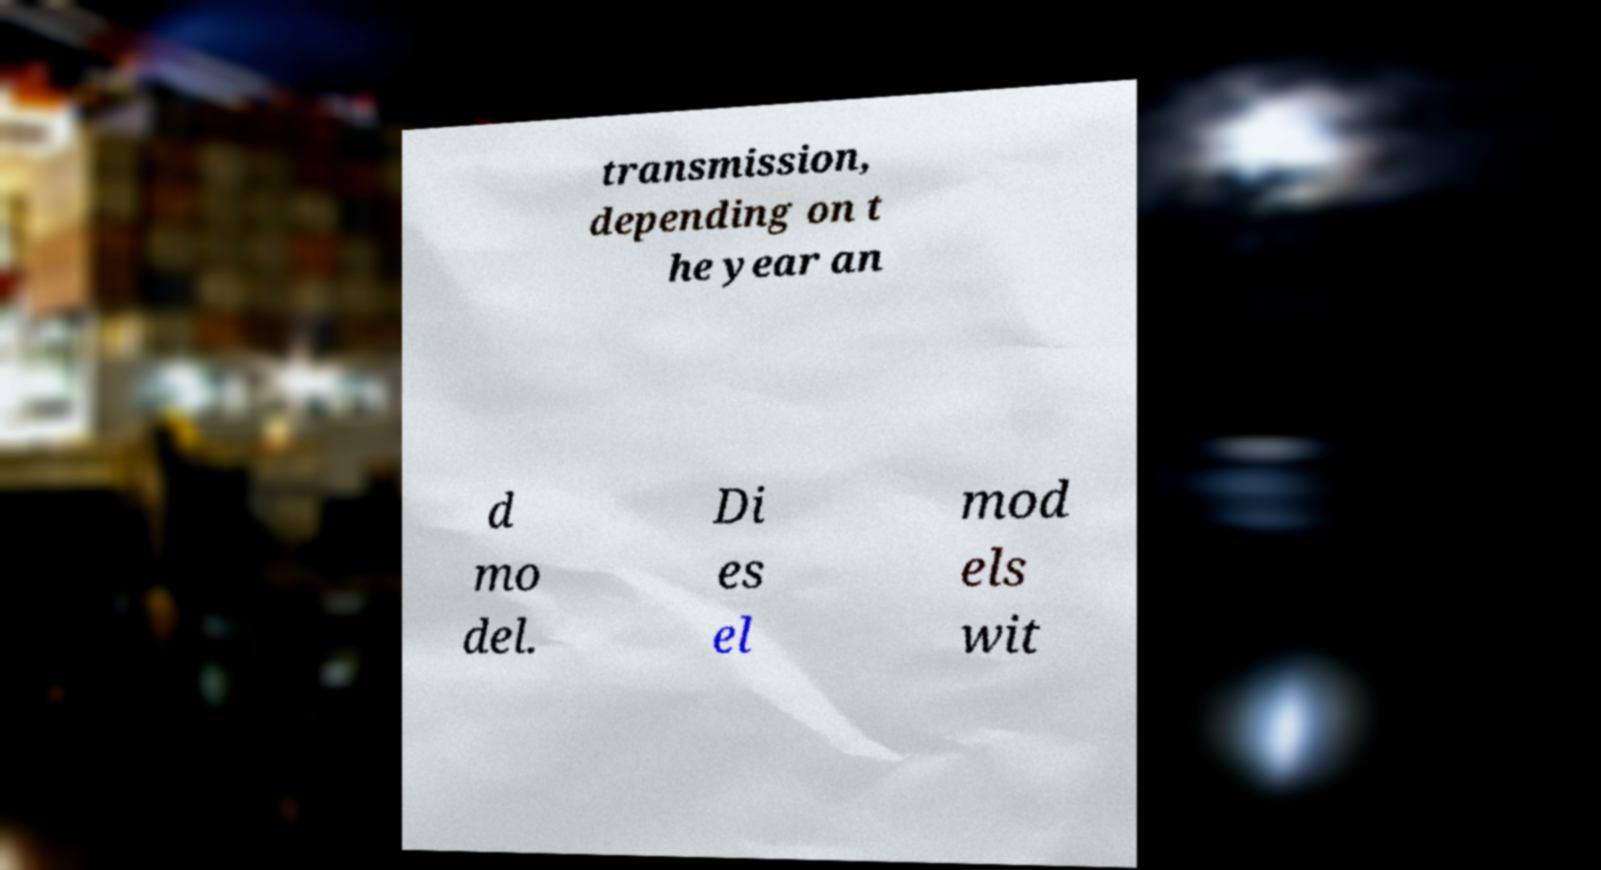There's text embedded in this image that I need extracted. Can you transcribe it verbatim? transmission, depending on t he year an d mo del. Di es el mod els wit 